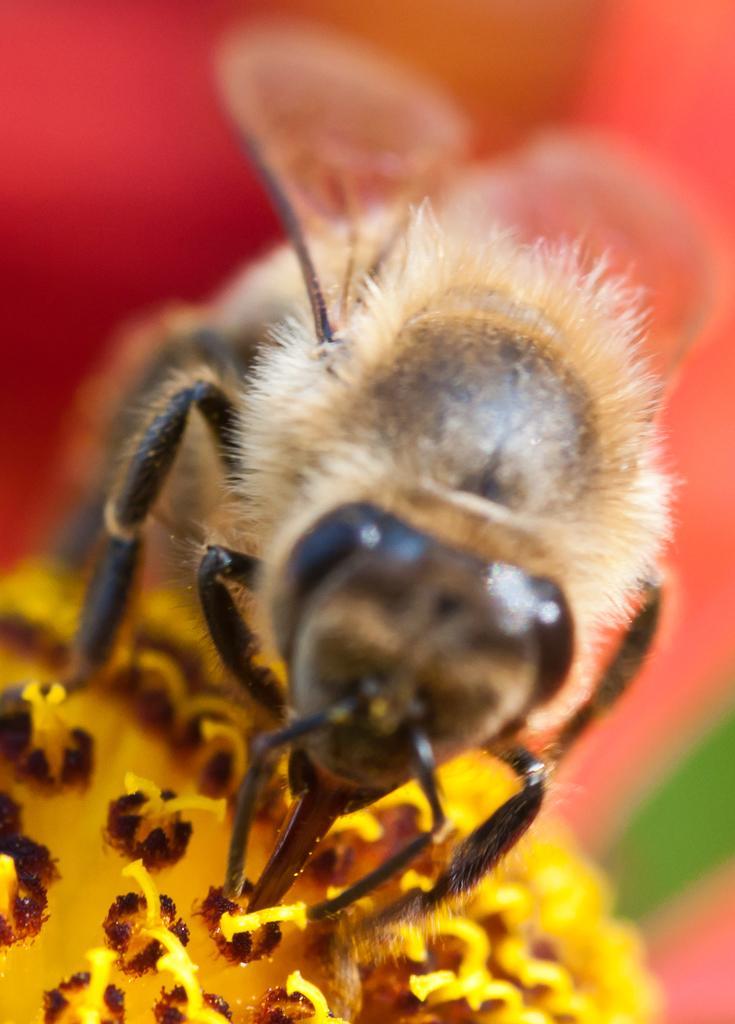Please provide a concise description of this image. In this image there is a insect on the flower , and there is blur background. 